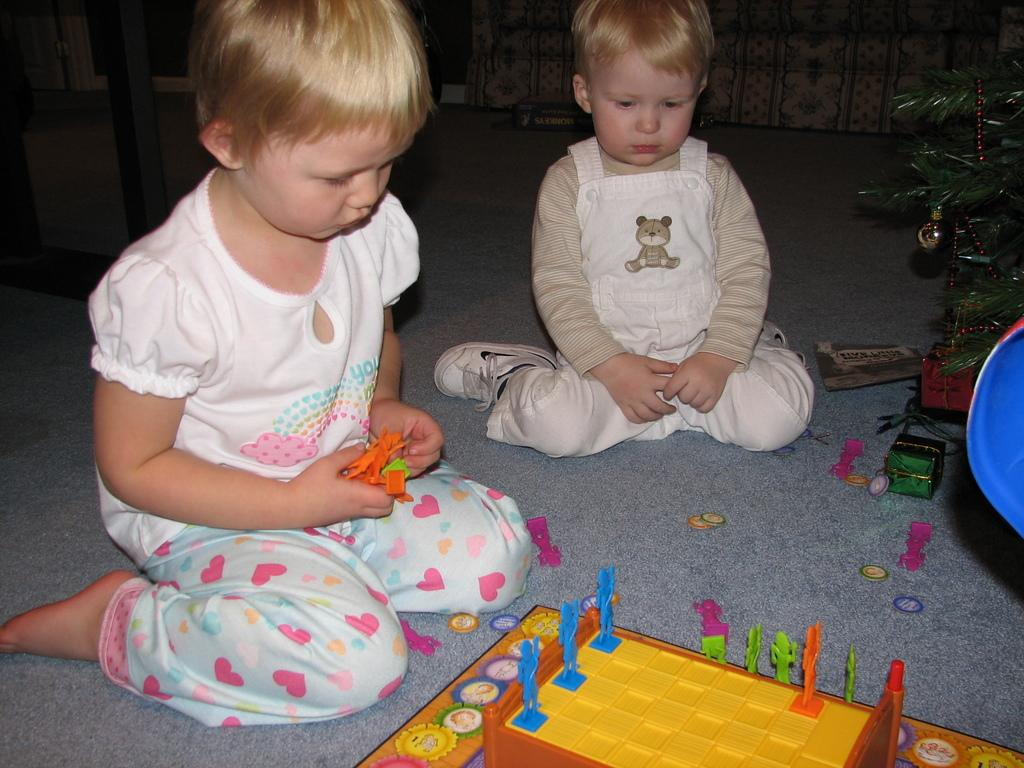How many children are present in the image? There are two children in the image. What are the children doing in the image? The children are sitting on the floor. What is one of the children holding? One of the children is holding an orange-colored object. What else can be seen on the floor in the image? There are toys and a plant on the floor. What is the smell of the plant in the image? The image does not provide information about the smell of the plant, so it cannot be determined from the image. 